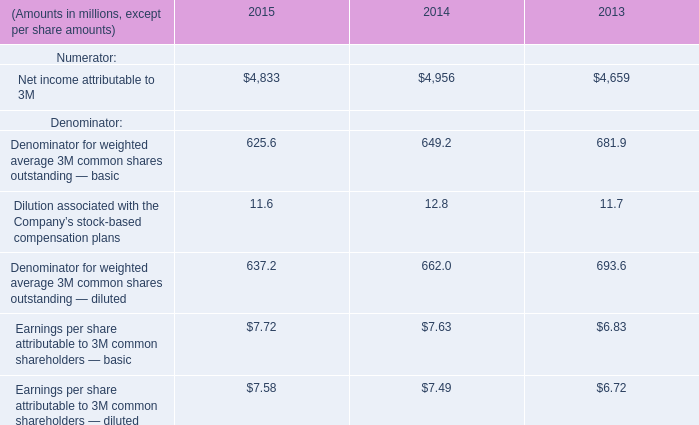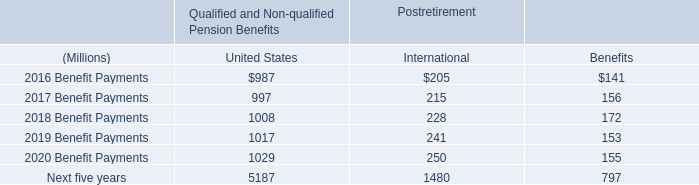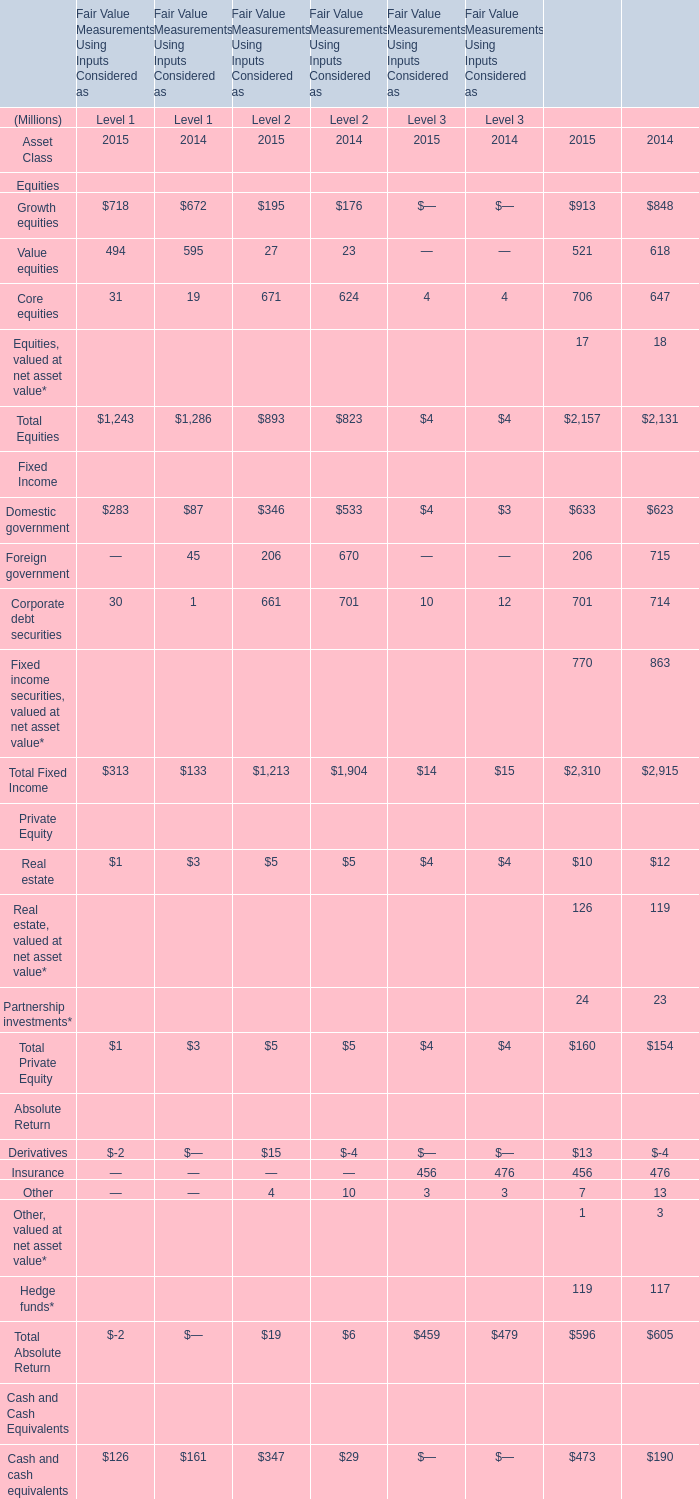In the Level with largest amount of Total Fixed Income in 2015, what's the sum of Total Absolute Return in 2015? (in million) 
Answer: 19. 